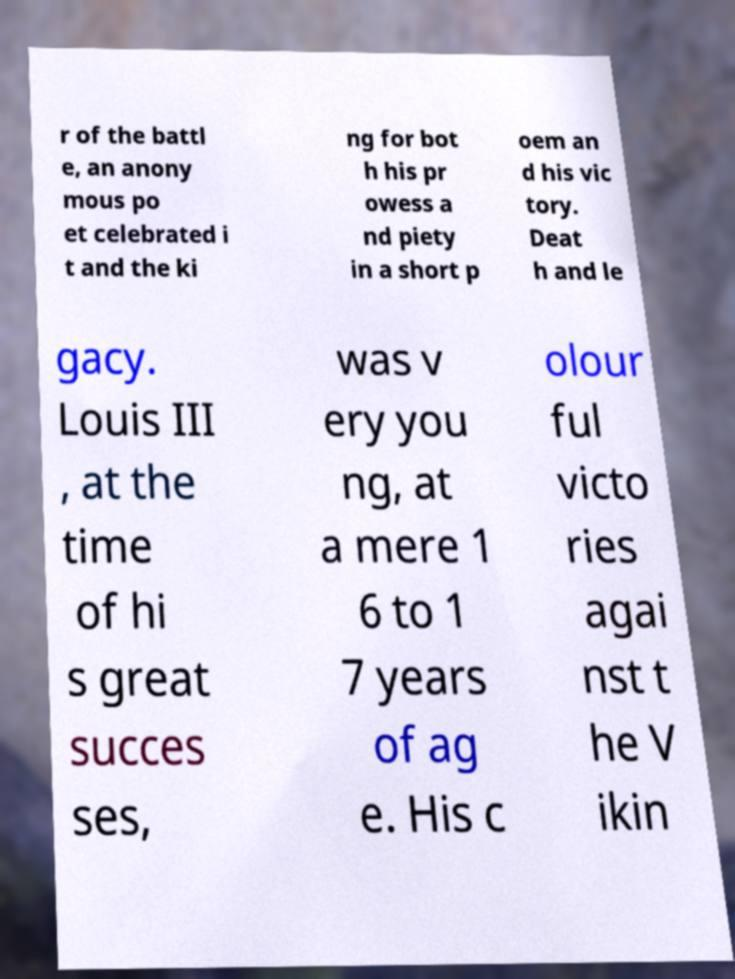Please read and relay the text visible in this image. What does it say? r of the battl e, an anony mous po et celebrated i t and the ki ng for bot h his pr owess a nd piety in a short p oem an d his vic tory. Deat h and le gacy. Louis III , at the time of hi s great succes ses, was v ery you ng, at a mere 1 6 to 1 7 years of ag e. His c olour ful victo ries agai nst t he V ikin 